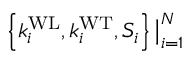<formula> <loc_0><loc_0><loc_500><loc_500>\left \{ k _ { i } ^ { W L } , k _ { i } ^ { W T } , S _ { i } \right \} \Big | _ { i = 1 } ^ { N }</formula> 